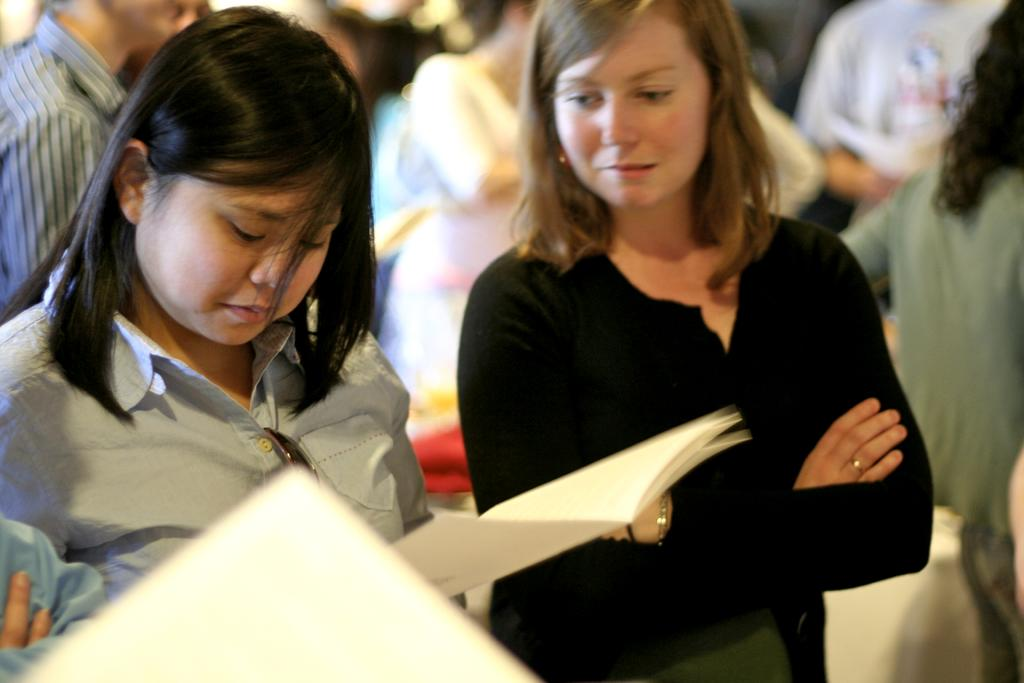How many women are in the foreground of the image? There are two women in the foreground of the image. What is the first woman holding? The first woman is holding some books. Can you describe the background of the image? There are other people visible behind the two women. What type of dust can be seen on the cork in the image? There is no dust or cork present in the image. 